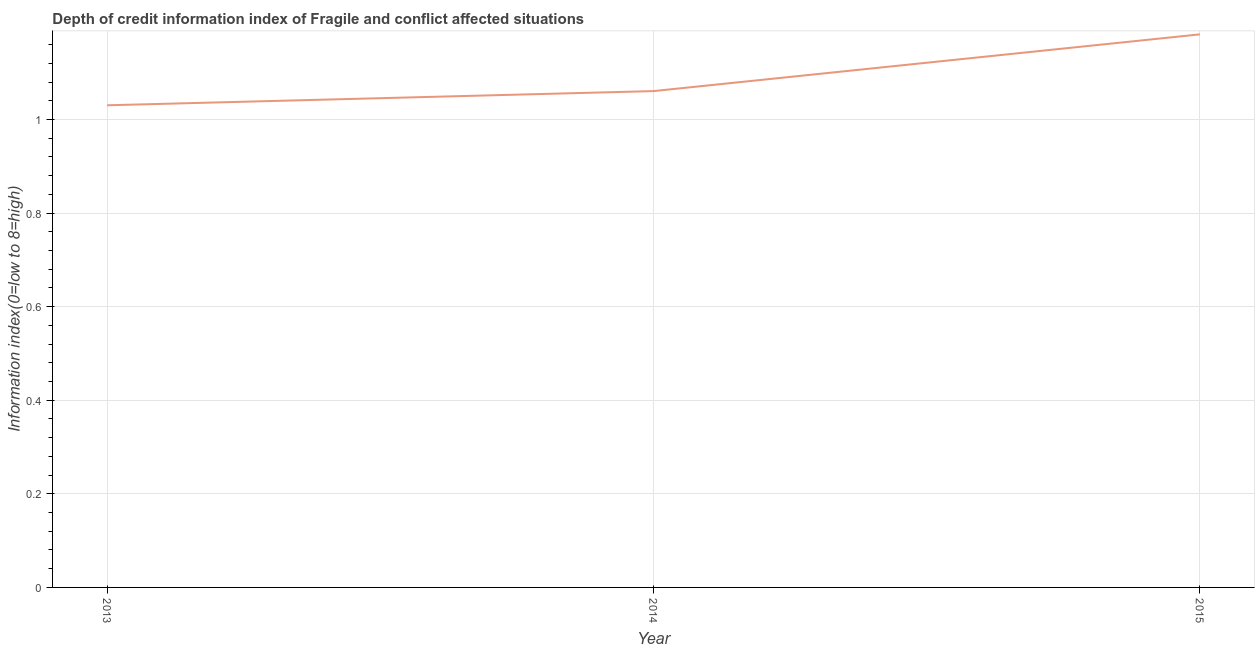What is the depth of credit information index in 2014?
Your response must be concise. 1.06. Across all years, what is the maximum depth of credit information index?
Ensure brevity in your answer.  1.18. Across all years, what is the minimum depth of credit information index?
Offer a very short reply. 1.03. In which year was the depth of credit information index maximum?
Make the answer very short. 2015. What is the sum of the depth of credit information index?
Provide a short and direct response. 3.27. What is the difference between the depth of credit information index in 2013 and 2015?
Your response must be concise. -0.15. What is the average depth of credit information index per year?
Provide a short and direct response. 1.09. What is the median depth of credit information index?
Provide a short and direct response. 1.06. What is the ratio of the depth of credit information index in 2013 to that in 2015?
Provide a succinct answer. 0.87. What is the difference between the highest and the second highest depth of credit information index?
Offer a very short reply. 0.12. What is the difference between the highest and the lowest depth of credit information index?
Provide a succinct answer. 0.15. In how many years, is the depth of credit information index greater than the average depth of credit information index taken over all years?
Provide a succinct answer. 1. How many lines are there?
Your answer should be very brief. 1. Does the graph contain any zero values?
Give a very brief answer. No. What is the title of the graph?
Your answer should be compact. Depth of credit information index of Fragile and conflict affected situations. What is the label or title of the Y-axis?
Your response must be concise. Information index(0=low to 8=high). What is the Information index(0=low to 8=high) of 2013?
Keep it short and to the point. 1.03. What is the Information index(0=low to 8=high) of 2014?
Your response must be concise. 1.06. What is the Information index(0=low to 8=high) in 2015?
Offer a terse response. 1.18. What is the difference between the Information index(0=low to 8=high) in 2013 and 2014?
Offer a terse response. -0.03. What is the difference between the Information index(0=low to 8=high) in 2013 and 2015?
Make the answer very short. -0.15. What is the difference between the Information index(0=low to 8=high) in 2014 and 2015?
Ensure brevity in your answer.  -0.12. What is the ratio of the Information index(0=low to 8=high) in 2013 to that in 2014?
Offer a terse response. 0.97. What is the ratio of the Information index(0=low to 8=high) in 2013 to that in 2015?
Your answer should be compact. 0.87. What is the ratio of the Information index(0=low to 8=high) in 2014 to that in 2015?
Your answer should be compact. 0.9. 